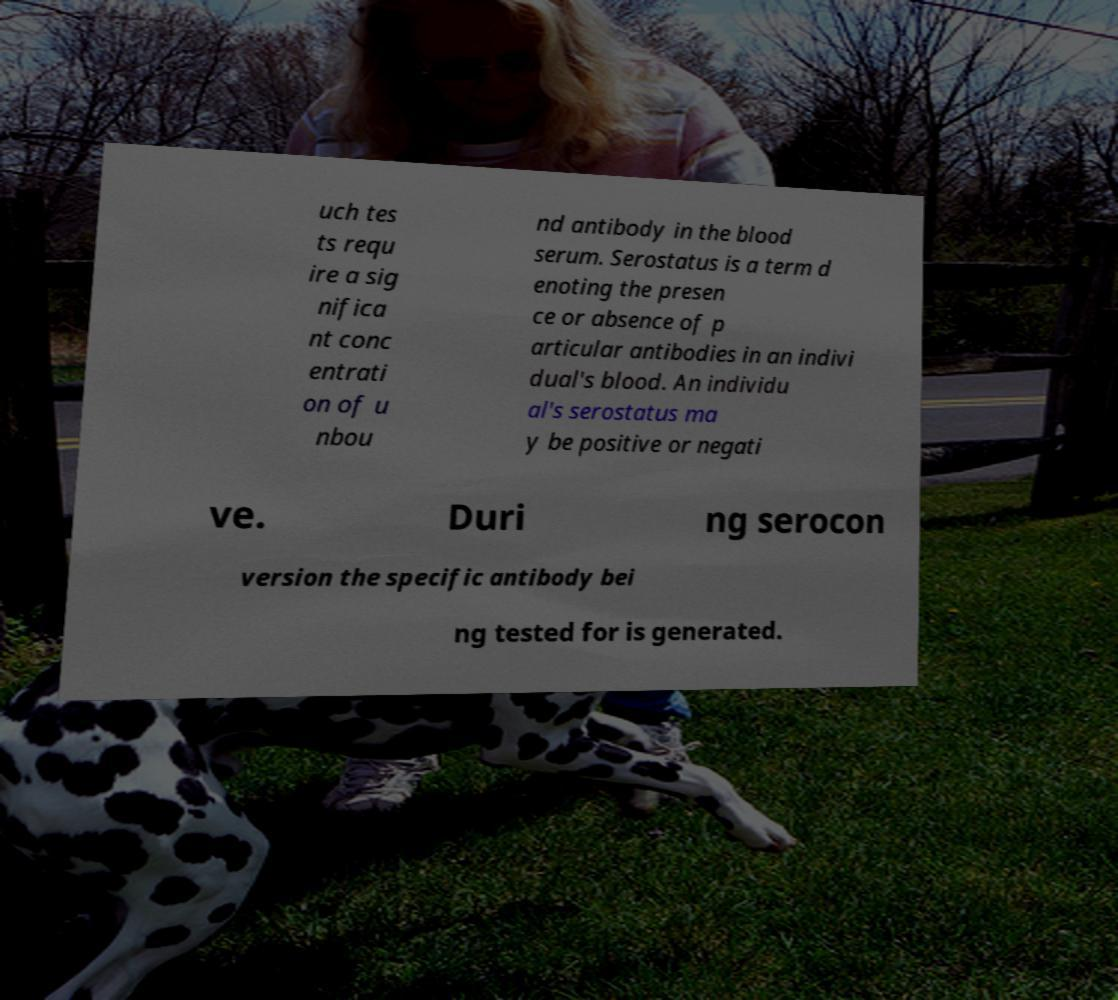I need the written content from this picture converted into text. Can you do that? uch tes ts requ ire a sig nifica nt conc entrati on of u nbou nd antibody in the blood serum. Serostatus is a term d enoting the presen ce or absence of p articular antibodies in an indivi dual's blood. An individu al's serostatus ma y be positive or negati ve. Duri ng serocon version the specific antibody bei ng tested for is generated. 